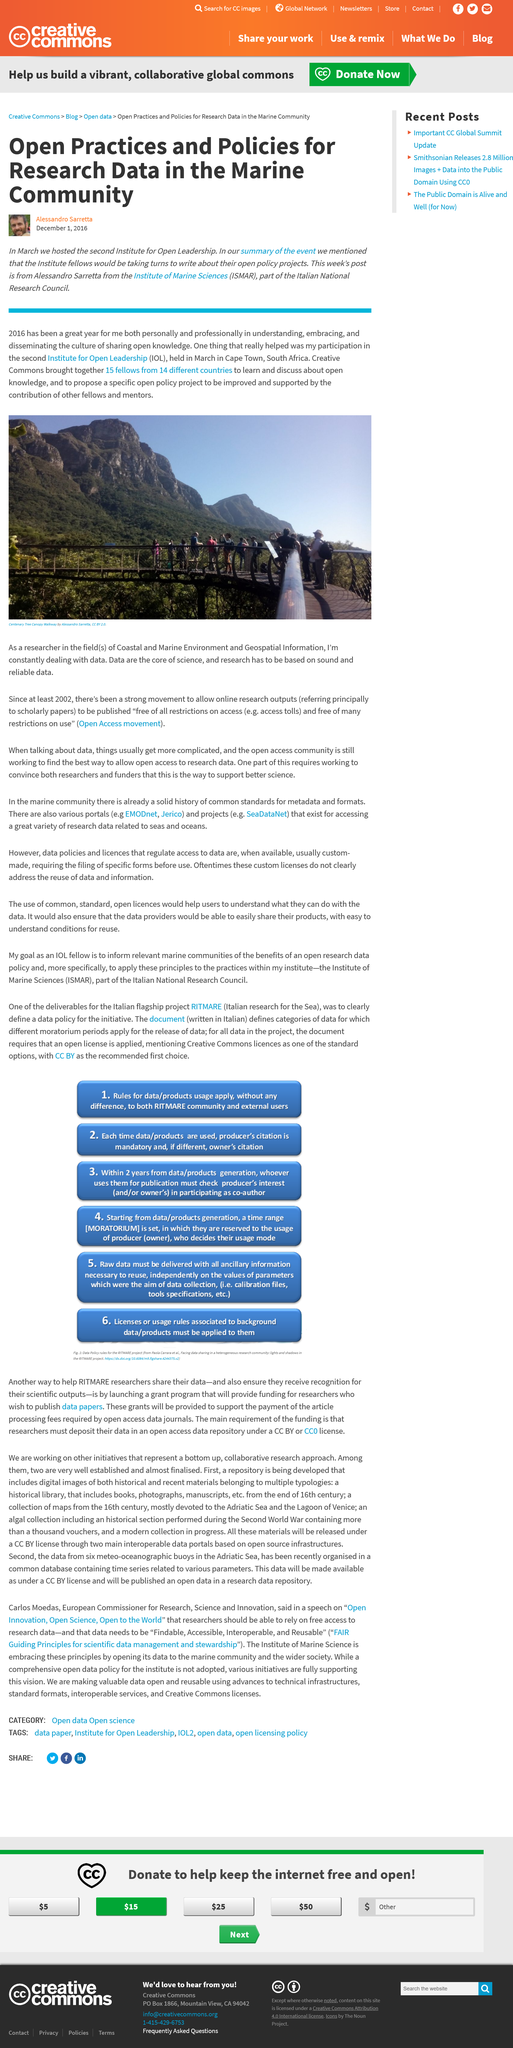Point out several critical features in this image. Alessandro Sarretta is a researcher from the Institute of Marine Sciences. The second Institute for Open Leadership was held in March. The second Institute for Leadership was held in Cape Town, South Africa. 